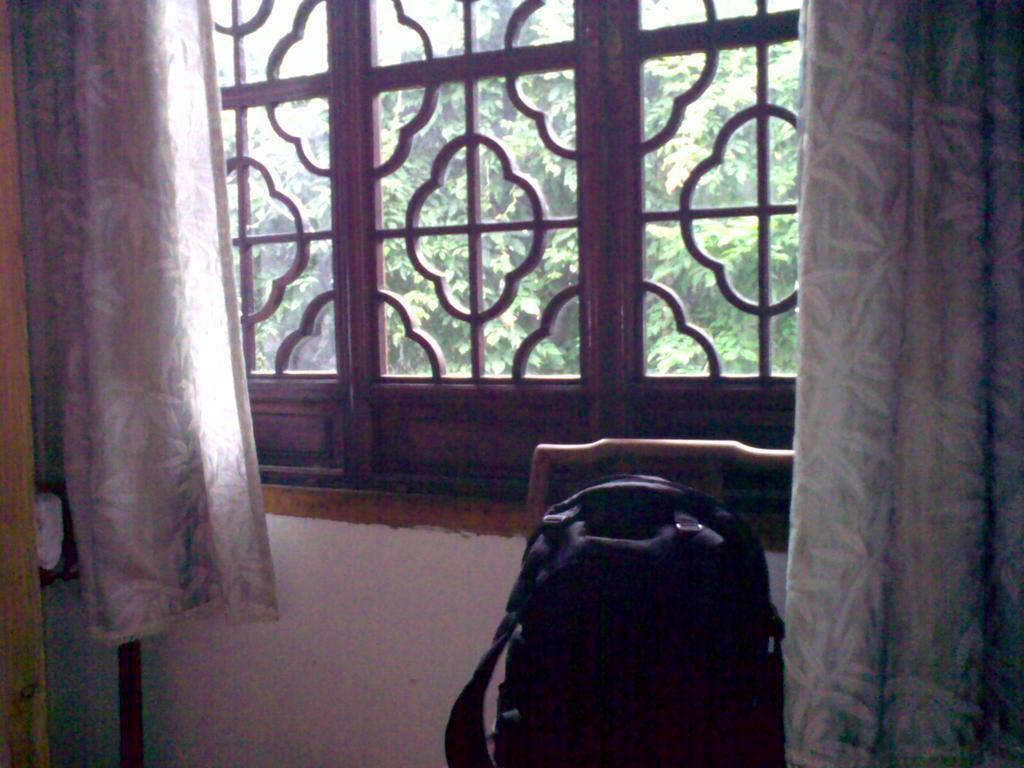Could you give a brief overview of what you see in this image? In this picture I can see there is a chair and there is a bag on it. In the backdrop there is a window and there is a curtain here and there are trees visible from the window. 